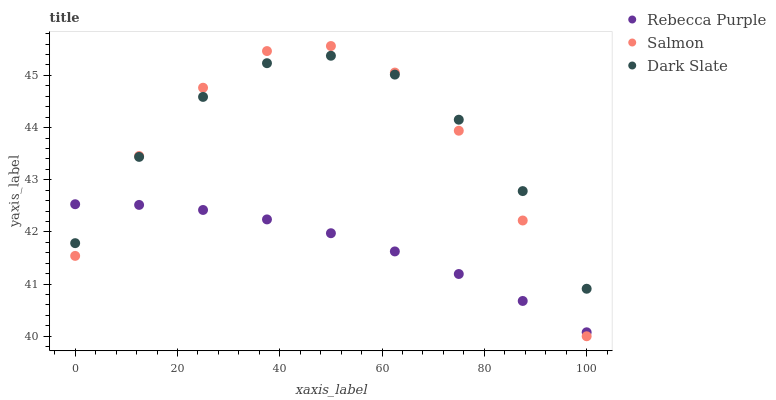Does Rebecca Purple have the minimum area under the curve?
Answer yes or no. Yes. Does Dark Slate have the maximum area under the curve?
Answer yes or no. Yes. Does Salmon have the minimum area under the curve?
Answer yes or no. No. Does Salmon have the maximum area under the curve?
Answer yes or no. No. Is Rebecca Purple the smoothest?
Answer yes or no. Yes. Is Salmon the roughest?
Answer yes or no. Yes. Is Salmon the smoothest?
Answer yes or no. No. Is Rebecca Purple the roughest?
Answer yes or no. No. Does Salmon have the lowest value?
Answer yes or no. Yes. Does Rebecca Purple have the lowest value?
Answer yes or no. No. Does Salmon have the highest value?
Answer yes or no. Yes. Does Rebecca Purple have the highest value?
Answer yes or no. No. Does Dark Slate intersect Rebecca Purple?
Answer yes or no. Yes. Is Dark Slate less than Rebecca Purple?
Answer yes or no. No. Is Dark Slate greater than Rebecca Purple?
Answer yes or no. No. 